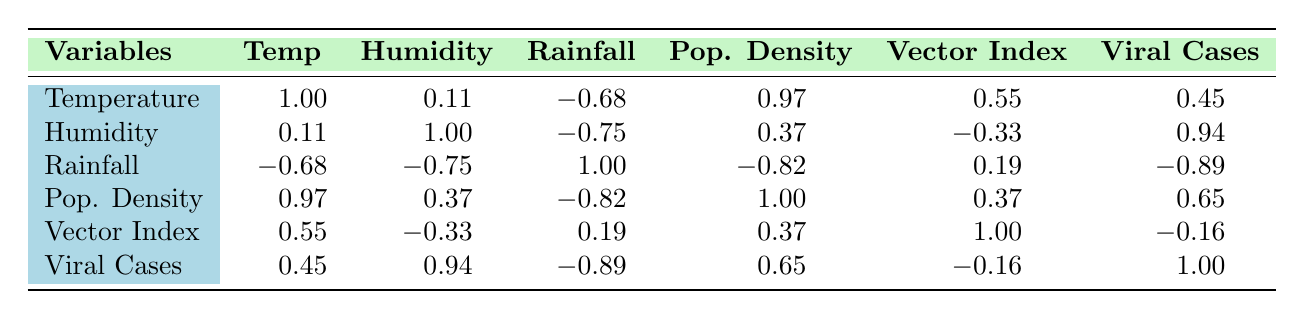What is the correlation between average temperature and viral infection cases? The table shows a correlation coefficient of 0.45 between temperature and viral cases, indicating a moderate positive correlation; as average temperature increases, viral cases tend to increase.
Answer: 0.45 What was the average rainfall in millimeters from 2020 to 2023? To find the average, sum the rainfall values: (1200 + 900 + 800 + 1100) = 4000 mm. Divide by the number of years (4): 4000 / 4 = 1000 mm.
Answer: 1000 mm Is there a strong correlation between humidity and viral infection cases? The table indicates a correlation coefficient of 0.94 between humidity and viral infection cases, which is considered a strong positive correlation. This suggests that as humidity increases, the number of viral infection cases also tends to increase.
Answer: Yes What is the correlation between rainfall and viral infection cases? The table shows a correlation of -0.89, indicating a strong negative correlation; as rainfall increases, viral cases tend to decrease.
Answer: -0.89 What is the difference in average population density between 2020 and 2023? The population density in 2020 is 455 per sq km, and in 2023 it is 475 per sq km. The difference is 475 - 455 = 20 per sq km.
Answer: 20 per sq km Which year had the highest average temperature, and what was its value? According to the table, 2023 had the highest average temperature at 31.5 degrees Celsius.
Answer: 2023, 31.5 degrees Celsius What can be concluded about the relationship between vector population index and viral infection cases from the table? The correlation coefficient between the vector population index and viral cases is -0.16, indicating a very weak negative correlation. This suggests that variations in vector population do not significantly impact viral infection cases.
Answer: Weak negative correlation What is the total number of viral infection cases reported in 2021 and 2022? To find the total, sum the cases from both years: 20000 (2021) + 25000 (2022) = 45000.
Answer: 45000 